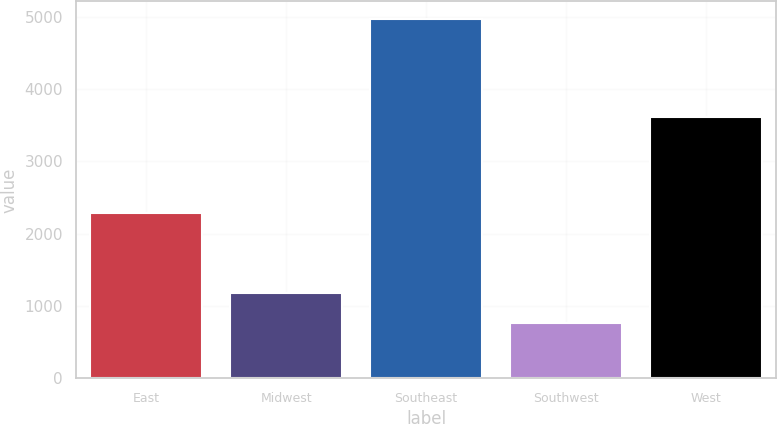Convert chart. <chart><loc_0><loc_0><loc_500><loc_500><bar_chart><fcel>East<fcel>Midwest<fcel>Southeast<fcel>Southwest<fcel>West<nl><fcel>2285<fcel>1180.94<fcel>4964<fcel>760.6<fcel>3610.3<nl></chart> 